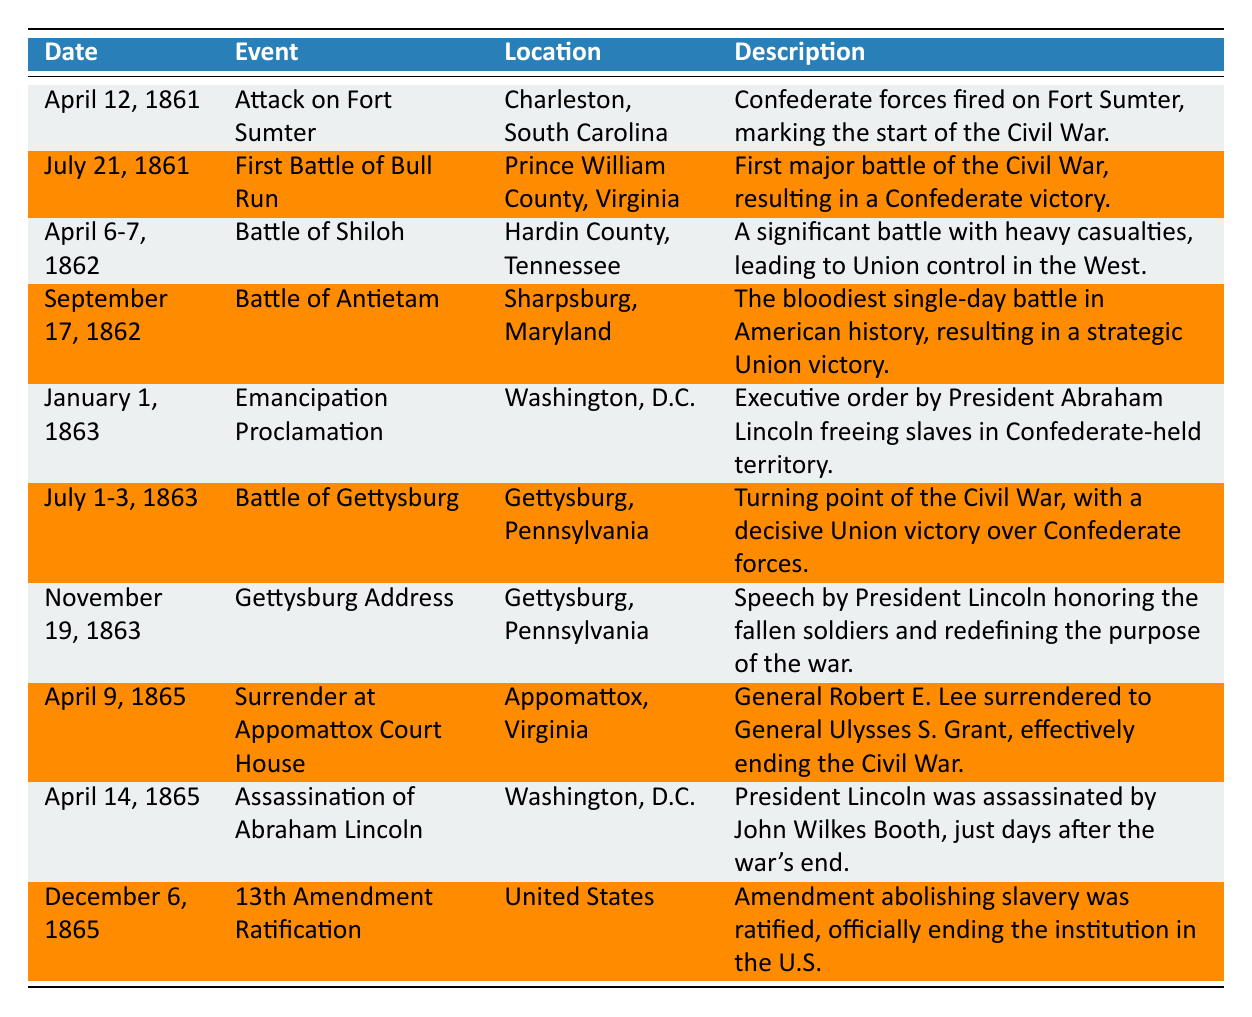What was the date of the Attack on Fort Sumter? The Attack on Fort Sumter occurred on the first entry of the table, which lists the date as April 12, 1861.
Answer: April 12, 1861 Which event took place in Washington, D.C.? Two events in the table occurred in Washington, D.C.: the Emancipation Proclamation and the Assassination of Abraham Lincoln.
Answer: Emancipation Proclamation and Assassination of Abraham Lincoln What was the last key event of the Civil War listed in the table? The last event in the table is the ratification of the 13th Amendment, which took place on December 6, 1865.
Answer: 13th Amendment Ratification What percentage of the events resulted in a Union victory? There are 10 events listed in the table. The events that clearly indicate a Union victory are the Battle of Antietam, the Battle of Gettysburg, and the Surrender at Appomattox Court House (3 events total). Therefore, the percentage is (3/10) * 100 = 30%.
Answer: 30% Is the Gettysburg Address listed before or after the Battle of Gettysburg in the table? The Gettysburg Address is listed on November 19, 1863, while the Battle of Gettysburg occurred from July 1-3, 1863, making the address listed after the battle.
Answer: After Which location appears most frequently in the events listed? Upon examining the locations in the table, "Washington, D.C." appears twice, while other locations appear only once. Therefore, Washington, D.C. is the most frequently listed location.
Answer: Washington, D.C How many events occurred in the year 1865? From the table, there are three events in 1865: the Surrender at Appomattox Court House on April 9, the Assassination of Abraham Lincoln on April 14, and the 13th Amendment Ratification on December 6. Thus, the count is 3 events.
Answer: 3 What was the outcome of the Battle of Antietam? The table states that the Battle of Antietam was the bloodiest single-day battle in American history, resulting in a strategic Union victory. This indicates the outcome was favorable for the Union.
Answer: Union victory What major action did President Abraham Lincoln take on January 1, 1863? On that date, President Lincoln issued the Emancipation Proclamation, which is indicated in the table as freeing slaves in Confederate-held territory.
Answer: Emancipation Proclamation Did any events listed in the table take place in Tennessee? Yes, the Battle of Shiloh took place in Hardin County, Tennessee as noted in the table, confirming that at least one event occurred there.
Answer: Yes 